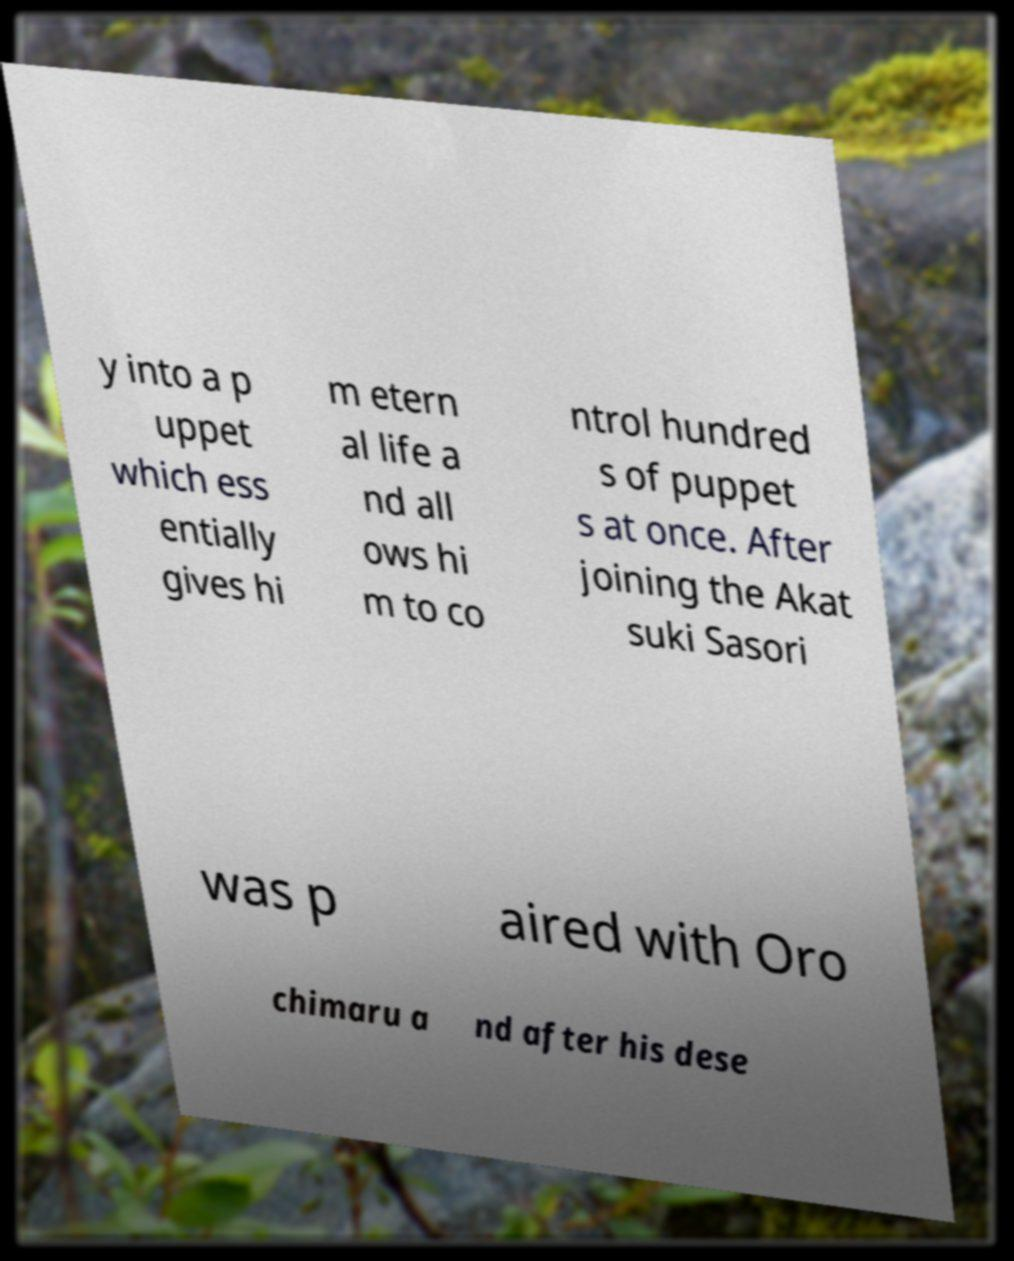Can you read and provide the text displayed in the image?This photo seems to have some interesting text. Can you extract and type it out for me? y into a p uppet which ess entially gives hi m etern al life a nd all ows hi m to co ntrol hundred s of puppet s at once. After joining the Akat suki Sasori was p aired with Oro chimaru a nd after his dese 